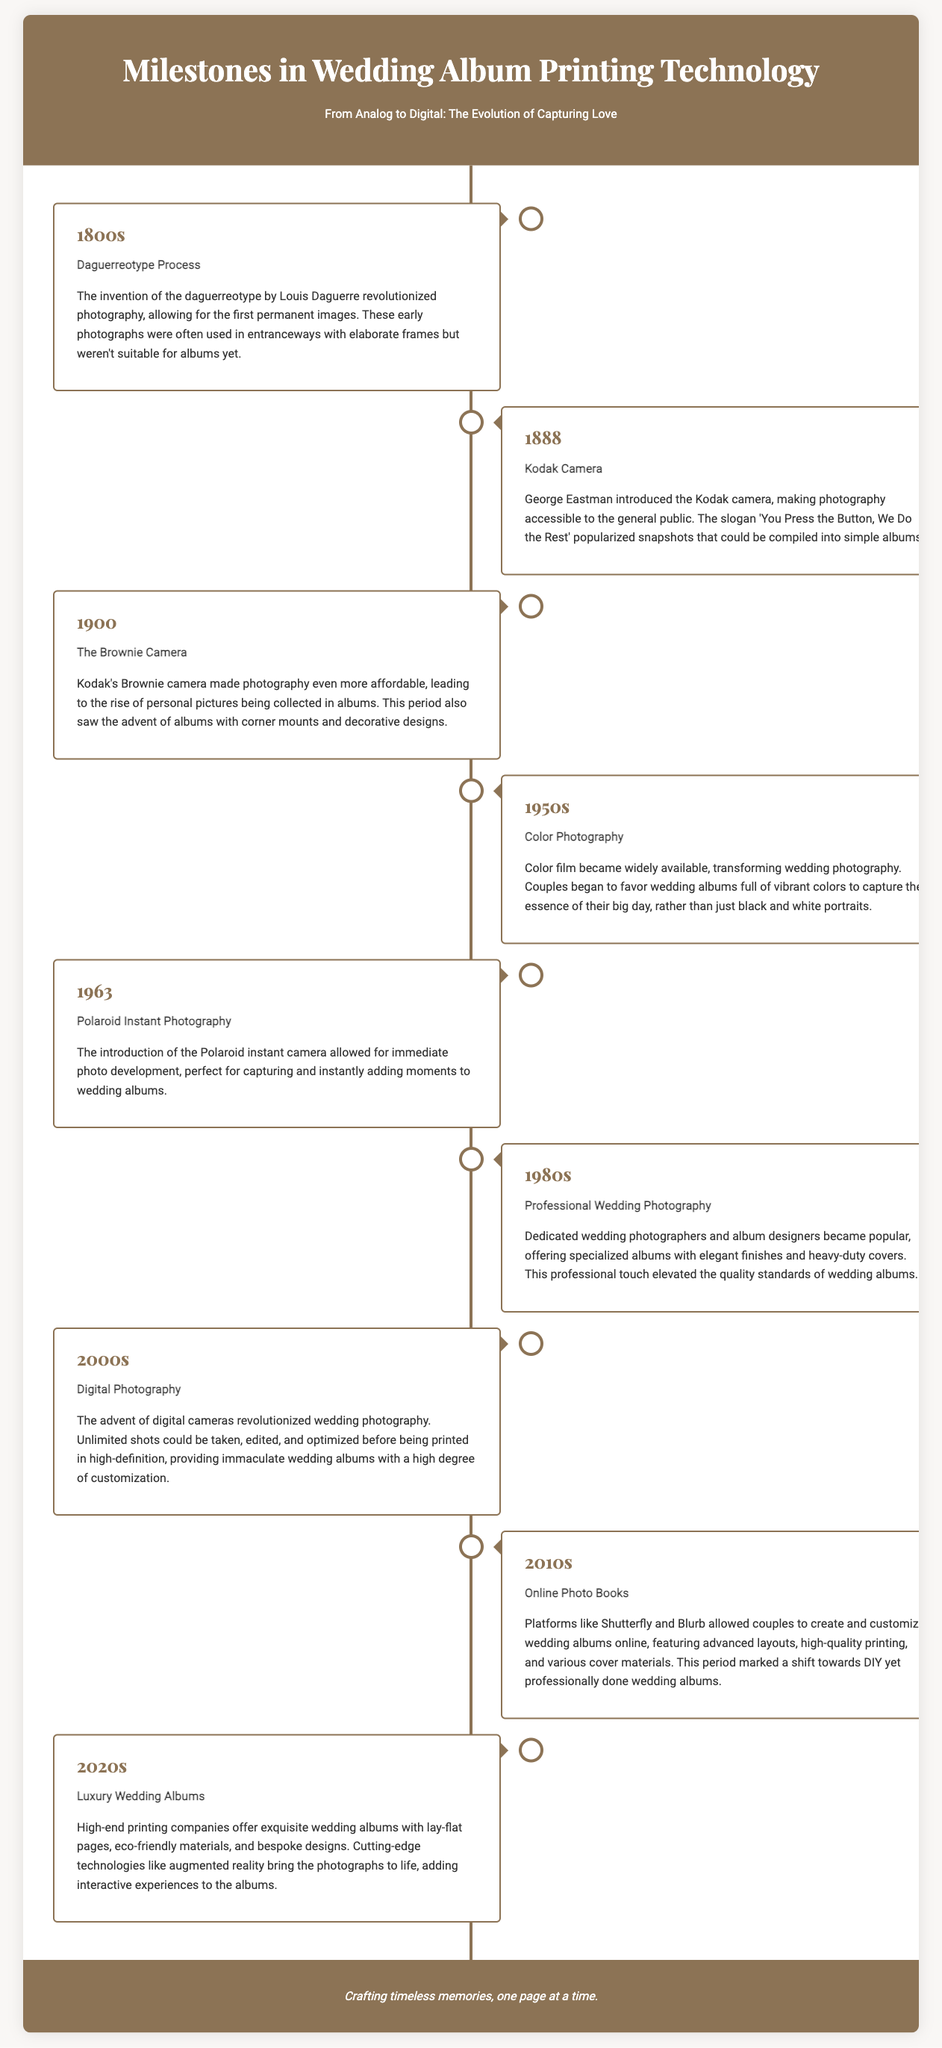What year was the Daguerreotype Process invented? The Daguerreotype Process was invented in the 1800s.
Answer: 1800s What was introduced by George Eastman in 1888? George Eastman introduced the Kodak camera in 1888.
Answer: Kodak camera Which camera made photography affordable in 1900? The Brownie camera made photography affordable in 1900.
Answer: Brownie camera What significant change happened in the 1950s regarding wedding albums? In the 1950s, color film became widely available for wedding albums.
Answer: Color photography What technology was introduced in 1963 that allowed for immediate photo development? The Polaroid instant camera was introduced in 1963.
Answer: Polaroid instant photography During which decade did professional wedding photography gain popularity? Professional wedding photography gained popularity in the 1980s.
Answer: 1980s What major advancement occurred in the 2000s for wedding photography? The advent of digital cameras revolutionized wedding photography in the 2000s.
Answer: Digital photography What online platforms emerged in the 2010s for creating wedding albums? Platforms like Shutterfly and Blurb emerged in the 2010s.
Answer: Shutterfly and Blurb What type of wedding albums became popular in the 2020s? Luxury wedding albums became popular in the 2020s.
Answer: Luxury Wedding Albums 